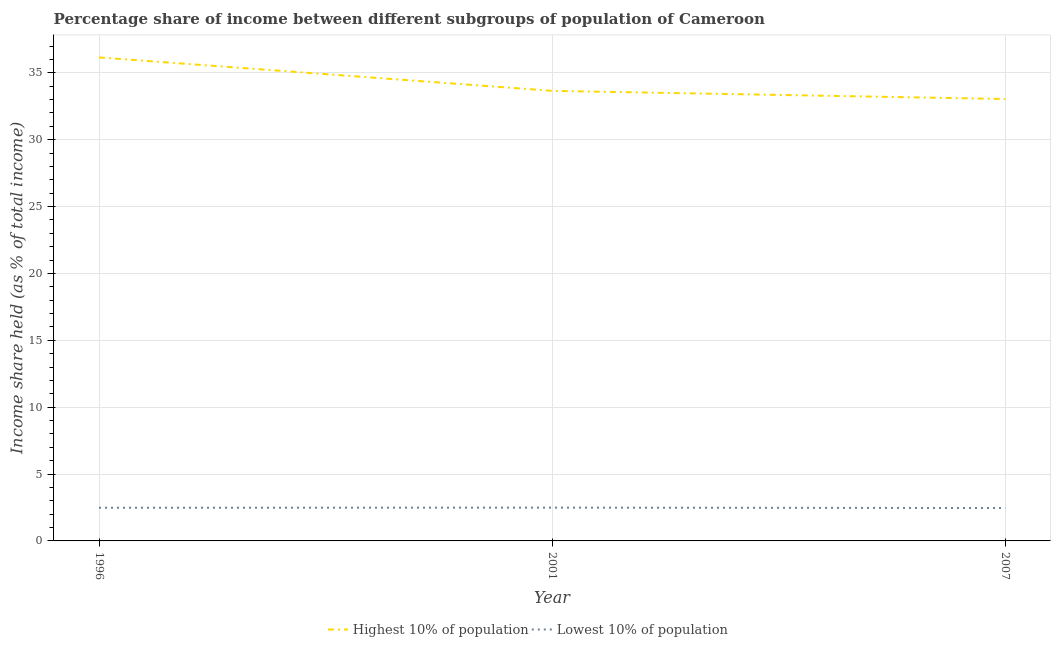Does the line corresponding to income share held by highest 10% of the population intersect with the line corresponding to income share held by lowest 10% of the population?
Make the answer very short. No. What is the income share held by highest 10% of the population in 2007?
Make the answer very short. 33.04. Across all years, what is the maximum income share held by highest 10% of the population?
Provide a short and direct response. 36.15. Across all years, what is the minimum income share held by lowest 10% of the population?
Make the answer very short. 2.46. What is the total income share held by lowest 10% of the population in the graph?
Provide a succinct answer. 7.43. What is the difference between the income share held by lowest 10% of the population in 1996 and that in 2001?
Your answer should be very brief. -0.01. What is the difference between the income share held by lowest 10% of the population in 1996 and the income share held by highest 10% of the population in 2001?
Give a very brief answer. -31.17. What is the average income share held by highest 10% of the population per year?
Your answer should be compact. 34.28. In the year 1996, what is the difference between the income share held by highest 10% of the population and income share held by lowest 10% of the population?
Keep it short and to the point. 33.67. What is the ratio of the income share held by lowest 10% of the population in 1996 to that in 2007?
Offer a terse response. 1.01. Is the difference between the income share held by lowest 10% of the population in 1996 and 2007 greater than the difference between the income share held by highest 10% of the population in 1996 and 2007?
Give a very brief answer. No. What is the difference between the highest and the second highest income share held by highest 10% of the population?
Provide a short and direct response. 2.5. What is the difference between the highest and the lowest income share held by lowest 10% of the population?
Your answer should be very brief. 0.03. Is the sum of the income share held by highest 10% of the population in 2001 and 2007 greater than the maximum income share held by lowest 10% of the population across all years?
Make the answer very short. Yes. Is the income share held by lowest 10% of the population strictly less than the income share held by highest 10% of the population over the years?
Provide a short and direct response. Yes. What is the difference between two consecutive major ticks on the Y-axis?
Give a very brief answer. 5. Does the graph contain any zero values?
Give a very brief answer. No. Does the graph contain grids?
Offer a very short reply. Yes. Where does the legend appear in the graph?
Offer a terse response. Bottom center. How are the legend labels stacked?
Make the answer very short. Horizontal. What is the title of the graph?
Provide a succinct answer. Percentage share of income between different subgroups of population of Cameroon. Does "Net savings(excluding particulate emission damage)" appear as one of the legend labels in the graph?
Ensure brevity in your answer.  No. What is the label or title of the X-axis?
Give a very brief answer. Year. What is the label or title of the Y-axis?
Give a very brief answer. Income share held (as % of total income). What is the Income share held (as % of total income) of Highest 10% of population in 1996?
Offer a very short reply. 36.15. What is the Income share held (as % of total income) in Lowest 10% of population in 1996?
Your answer should be compact. 2.48. What is the Income share held (as % of total income) of Highest 10% of population in 2001?
Keep it short and to the point. 33.65. What is the Income share held (as % of total income) in Lowest 10% of population in 2001?
Make the answer very short. 2.49. What is the Income share held (as % of total income) of Highest 10% of population in 2007?
Provide a succinct answer. 33.04. What is the Income share held (as % of total income) in Lowest 10% of population in 2007?
Keep it short and to the point. 2.46. Across all years, what is the maximum Income share held (as % of total income) of Highest 10% of population?
Offer a terse response. 36.15. Across all years, what is the maximum Income share held (as % of total income) of Lowest 10% of population?
Ensure brevity in your answer.  2.49. Across all years, what is the minimum Income share held (as % of total income) in Highest 10% of population?
Give a very brief answer. 33.04. Across all years, what is the minimum Income share held (as % of total income) of Lowest 10% of population?
Offer a very short reply. 2.46. What is the total Income share held (as % of total income) of Highest 10% of population in the graph?
Make the answer very short. 102.84. What is the total Income share held (as % of total income) in Lowest 10% of population in the graph?
Ensure brevity in your answer.  7.43. What is the difference between the Income share held (as % of total income) of Highest 10% of population in 1996 and that in 2001?
Make the answer very short. 2.5. What is the difference between the Income share held (as % of total income) in Lowest 10% of population in 1996 and that in 2001?
Provide a succinct answer. -0.01. What is the difference between the Income share held (as % of total income) in Highest 10% of population in 1996 and that in 2007?
Make the answer very short. 3.11. What is the difference between the Income share held (as % of total income) in Highest 10% of population in 2001 and that in 2007?
Make the answer very short. 0.61. What is the difference between the Income share held (as % of total income) of Lowest 10% of population in 2001 and that in 2007?
Give a very brief answer. 0.03. What is the difference between the Income share held (as % of total income) of Highest 10% of population in 1996 and the Income share held (as % of total income) of Lowest 10% of population in 2001?
Your answer should be very brief. 33.66. What is the difference between the Income share held (as % of total income) of Highest 10% of population in 1996 and the Income share held (as % of total income) of Lowest 10% of population in 2007?
Offer a very short reply. 33.69. What is the difference between the Income share held (as % of total income) of Highest 10% of population in 2001 and the Income share held (as % of total income) of Lowest 10% of population in 2007?
Provide a short and direct response. 31.19. What is the average Income share held (as % of total income) of Highest 10% of population per year?
Your response must be concise. 34.28. What is the average Income share held (as % of total income) in Lowest 10% of population per year?
Offer a terse response. 2.48. In the year 1996, what is the difference between the Income share held (as % of total income) of Highest 10% of population and Income share held (as % of total income) of Lowest 10% of population?
Provide a short and direct response. 33.67. In the year 2001, what is the difference between the Income share held (as % of total income) in Highest 10% of population and Income share held (as % of total income) in Lowest 10% of population?
Provide a short and direct response. 31.16. In the year 2007, what is the difference between the Income share held (as % of total income) of Highest 10% of population and Income share held (as % of total income) of Lowest 10% of population?
Give a very brief answer. 30.58. What is the ratio of the Income share held (as % of total income) of Highest 10% of population in 1996 to that in 2001?
Offer a terse response. 1.07. What is the ratio of the Income share held (as % of total income) of Lowest 10% of population in 1996 to that in 2001?
Make the answer very short. 1. What is the ratio of the Income share held (as % of total income) in Highest 10% of population in 1996 to that in 2007?
Provide a short and direct response. 1.09. What is the ratio of the Income share held (as % of total income) in Lowest 10% of population in 1996 to that in 2007?
Your answer should be very brief. 1.01. What is the ratio of the Income share held (as % of total income) of Highest 10% of population in 2001 to that in 2007?
Your answer should be very brief. 1.02. What is the ratio of the Income share held (as % of total income) of Lowest 10% of population in 2001 to that in 2007?
Your answer should be compact. 1.01. What is the difference between the highest and the second highest Income share held (as % of total income) of Highest 10% of population?
Offer a very short reply. 2.5. What is the difference between the highest and the lowest Income share held (as % of total income) of Highest 10% of population?
Offer a terse response. 3.11. What is the difference between the highest and the lowest Income share held (as % of total income) in Lowest 10% of population?
Keep it short and to the point. 0.03. 